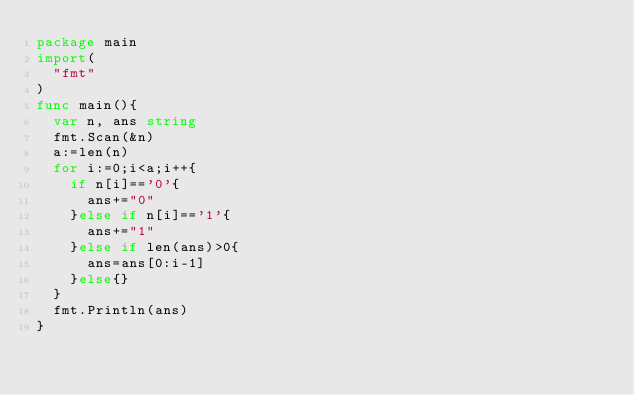<code> <loc_0><loc_0><loc_500><loc_500><_Go_>package main
import(
  "fmt"
)
func main(){
  var n, ans string
  fmt.Scan(&n)
  a:=len(n)
  for i:=0;i<a;i++{
    if n[i]=='0'{
      ans+="0"
    }else if n[i]=='1'{
      ans+="1"
    }else if len(ans)>0{
      ans=ans[0:i-1]
    }else{}
  }
  fmt.Println(ans)
}
</code> 